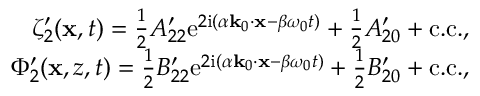<formula> <loc_0><loc_0><loc_500><loc_500>\begin{array} { r } { \zeta _ { 2 } ^ { \prime } ( x , t ) = \frac { 1 } { 2 } A _ { 2 2 } ^ { \prime } e ^ { 2 i ( \alpha k _ { 0 } \cdot x - \beta \omega _ { 0 } t ) } + \frac { 1 } { 2 } A _ { 2 0 } ^ { \prime } + c . c . , } \\ { \Phi _ { 2 } ^ { \prime } ( x , z , t ) = \frac { 1 } { 2 } B _ { 2 2 } ^ { \prime } e ^ { 2 i ( \alpha k _ { 0 } \cdot x - \beta \omega _ { 0 } t ) } + \frac { 1 } { 2 } B _ { 2 0 } ^ { \prime } + c . c . , } \end{array}</formula> 